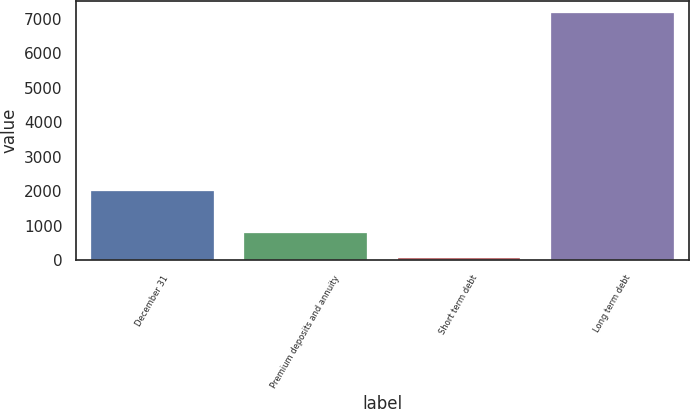<chart> <loc_0><loc_0><loc_500><loc_500><bar_chart><fcel>December 31<fcel>Premium deposits and annuity<fcel>Short term debt<fcel>Long term debt<nl><fcel>2008<fcel>780.5<fcel>71<fcel>7166<nl></chart> 